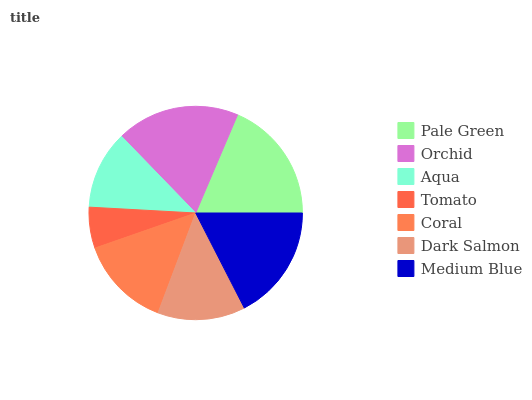Is Tomato the minimum?
Answer yes or no. Yes. Is Orchid the maximum?
Answer yes or no. Yes. Is Aqua the minimum?
Answer yes or no. No. Is Aqua the maximum?
Answer yes or no. No. Is Orchid greater than Aqua?
Answer yes or no. Yes. Is Aqua less than Orchid?
Answer yes or no. Yes. Is Aqua greater than Orchid?
Answer yes or no. No. Is Orchid less than Aqua?
Answer yes or no. No. Is Coral the high median?
Answer yes or no. Yes. Is Coral the low median?
Answer yes or no. Yes. Is Medium Blue the high median?
Answer yes or no. No. Is Pale Green the low median?
Answer yes or no. No. 